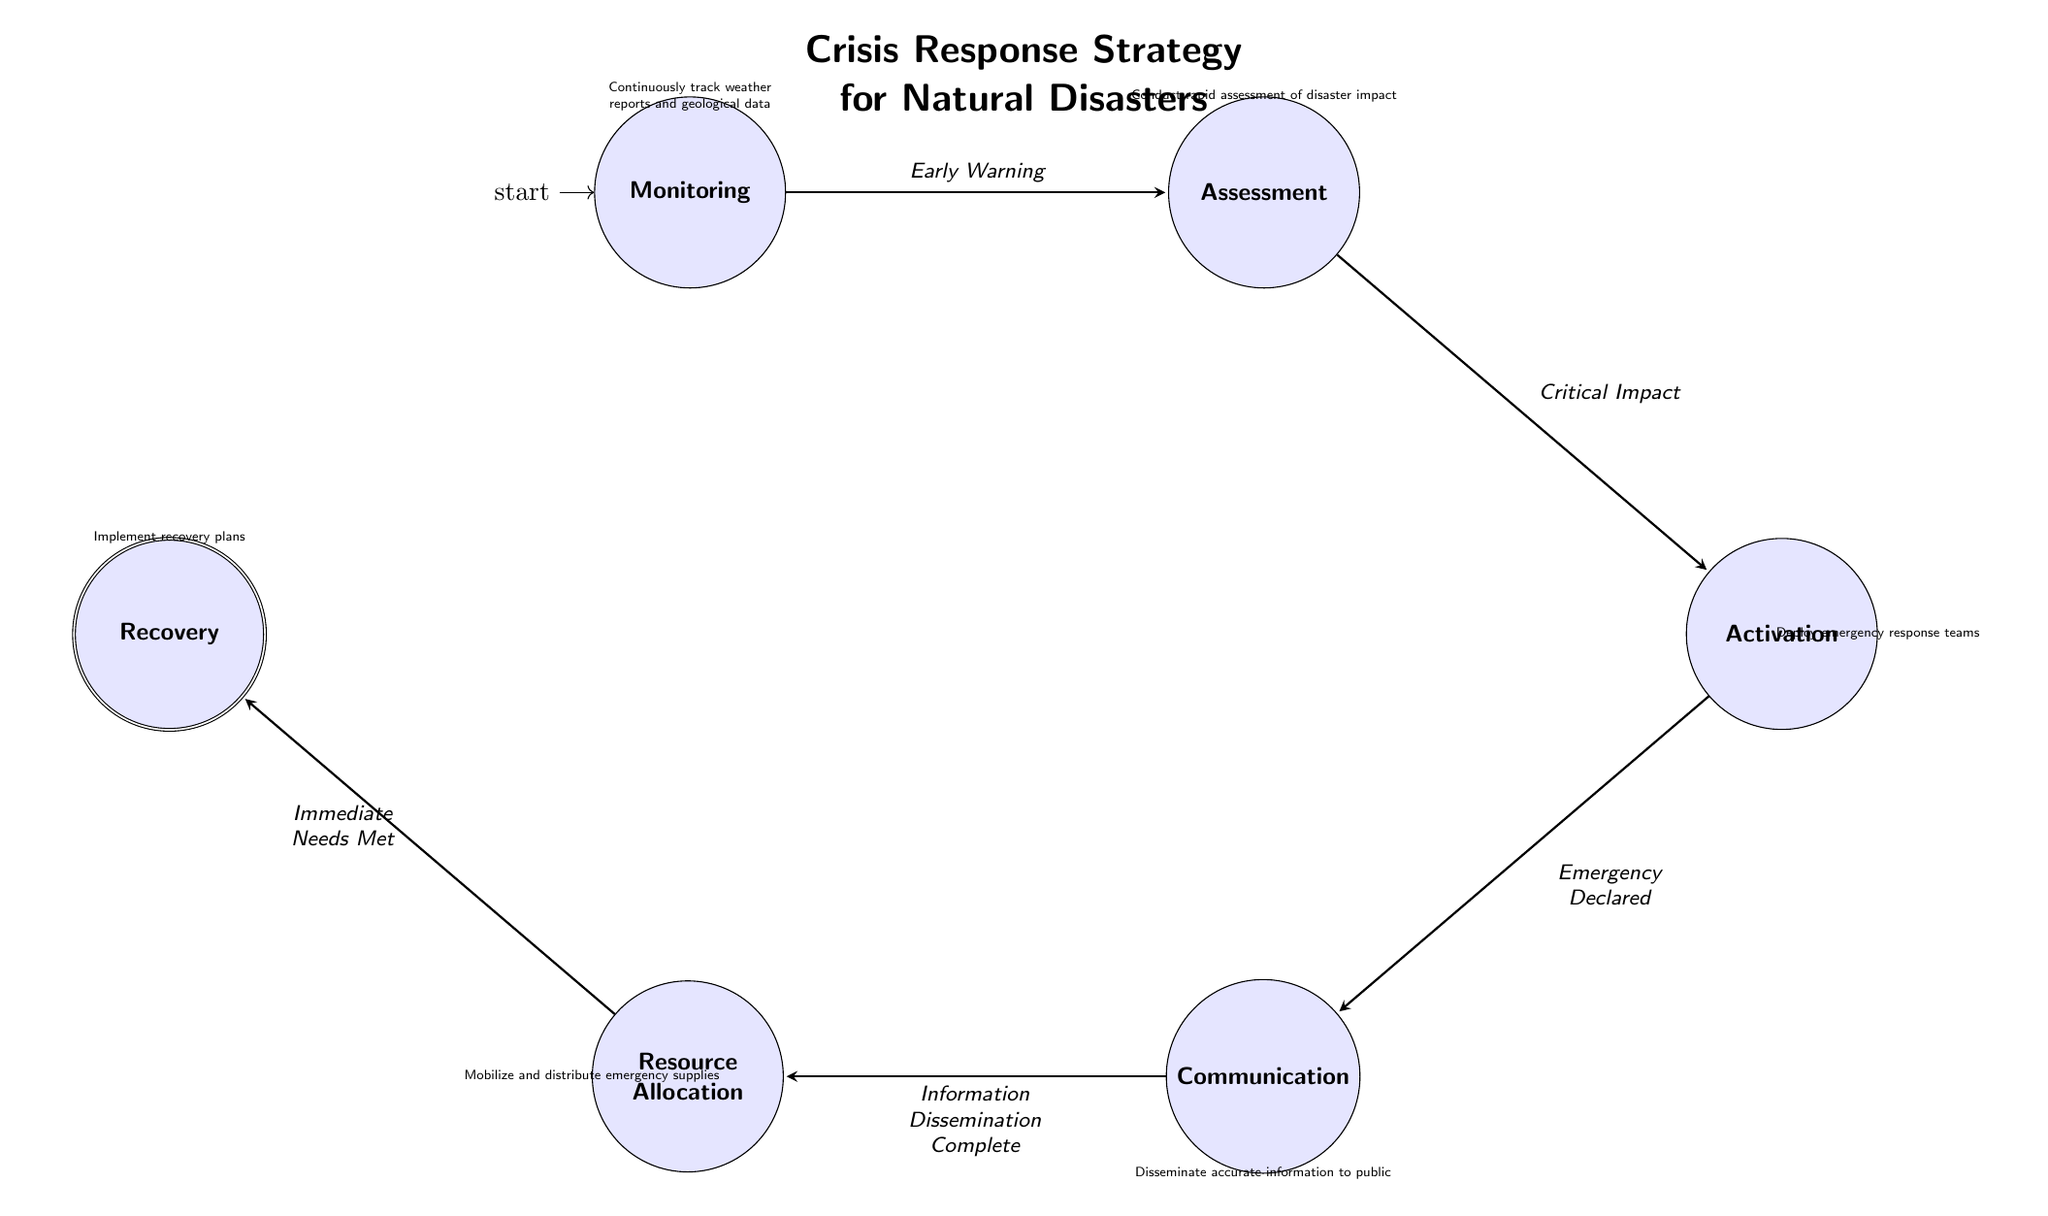What is the initial state of the diagram? The initial state is defined in the data as "Monitoring". The diagram starts processing from this state as indicated by the specific notation in the diagram.
Answer: Monitoring How many states are present in the diagram? The diagram lists six distinct states: Monitoring, Assessment, Activation, Communication, Resource Allocation, and Recovery. Therefore, there are six states in total.
Answer: 6 What state follows "Activation"? The transition from "Activation" leads to "Communication" as indicated in the diagram where an arrow points from Activation to Communication.
Answer: Communication What trigger causes the transition from "Assessment" to "Activation"? The transition from "Assessment" to "Activation" occurs when the "Critical Impact" trigger is activated, as specified in the transitions list of the diagram.
Answer: Critical Impact Which state is final in this Finite State Machine? The final state of the diagram is defined as "Recovery". It is identified as the accepting state in the Finite State Machine, where the process concludes.
Answer: Recovery What is the relationship between "Communication" and "Resource Allocation"? The diagram shows a direct transition from "Communication" to "Resource Allocation" triggered by "Information Dissemination Complete," indicating a flow from one to the other in response to this trigger.
Answer: Information Dissemination Complete What happens in the "Monitoring" state? In the "Monitoring" state, continuous tracking of weather reports and geological data is conducted for early warning signs of natural disasters, as described in the state information.
Answer: Continuously track weather reports and geological data How many transitions are there in total? The transitions listed in the diagram summarize to five connections among the states. These connections denote the requirements for moving from one state to another.
Answer: 5 What is the trigger for moving from "Resource Allocation" to "Recovery"? The transition from "Resource Allocation" to "Recovery" is activated when "Immediate Needs Met" is confirmed as per the transition details outlined in the diagram.
Answer: Immediate Needs Met 